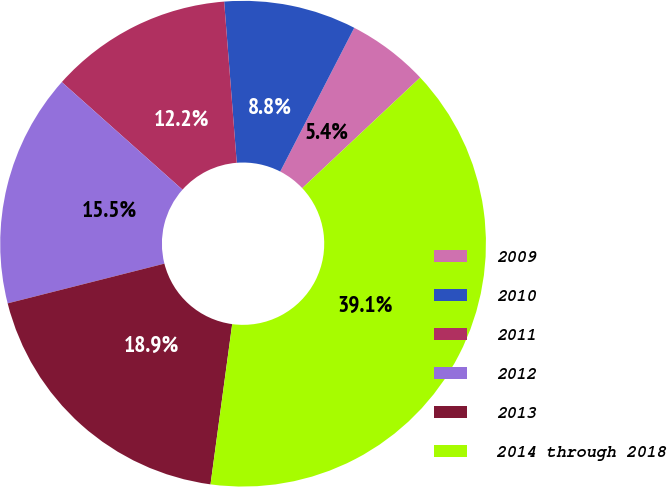Convert chart to OTSL. <chart><loc_0><loc_0><loc_500><loc_500><pie_chart><fcel>2009<fcel>2010<fcel>2011<fcel>2012<fcel>2013<fcel>2014 through 2018<nl><fcel>5.44%<fcel>8.81%<fcel>12.17%<fcel>15.54%<fcel>18.91%<fcel>39.13%<nl></chart> 